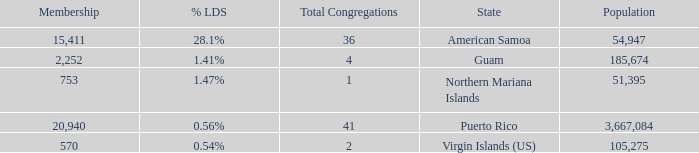What is the highest Population, when % LDS is 0.54%, and when Total Congregations is greater than 2? None. 